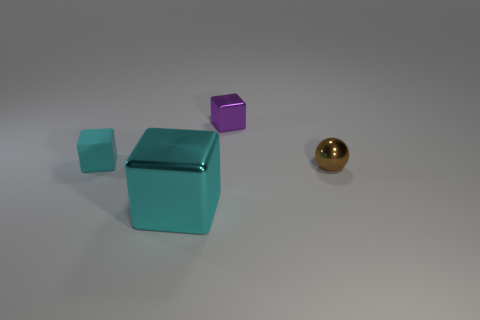How many rubber cubes have the same size as the sphere?
Provide a short and direct response. 1. Is the color of the small rubber thing the same as the big block?
Offer a very short reply. Yes. Are the cyan object that is in front of the brown metallic ball and the small thing that is right of the small purple block made of the same material?
Your response must be concise. Yes. Is the number of big cyan cubes greater than the number of small brown matte cylinders?
Your answer should be compact. Yes. Is there any other thing that has the same color as the small metal ball?
Offer a terse response. No. Does the large cyan cube have the same material as the brown ball?
Your response must be concise. Yes. Is the number of small purple shiny objects less than the number of yellow shiny blocks?
Your response must be concise. No. Does the tiny cyan rubber object have the same shape as the large cyan thing?
Your response must be concise. Yes. The large metallic block is what color?
Give a very brief answer. Cyan. How many other things are made of the same material as the brown thing?
Your response must be concise. 2. 